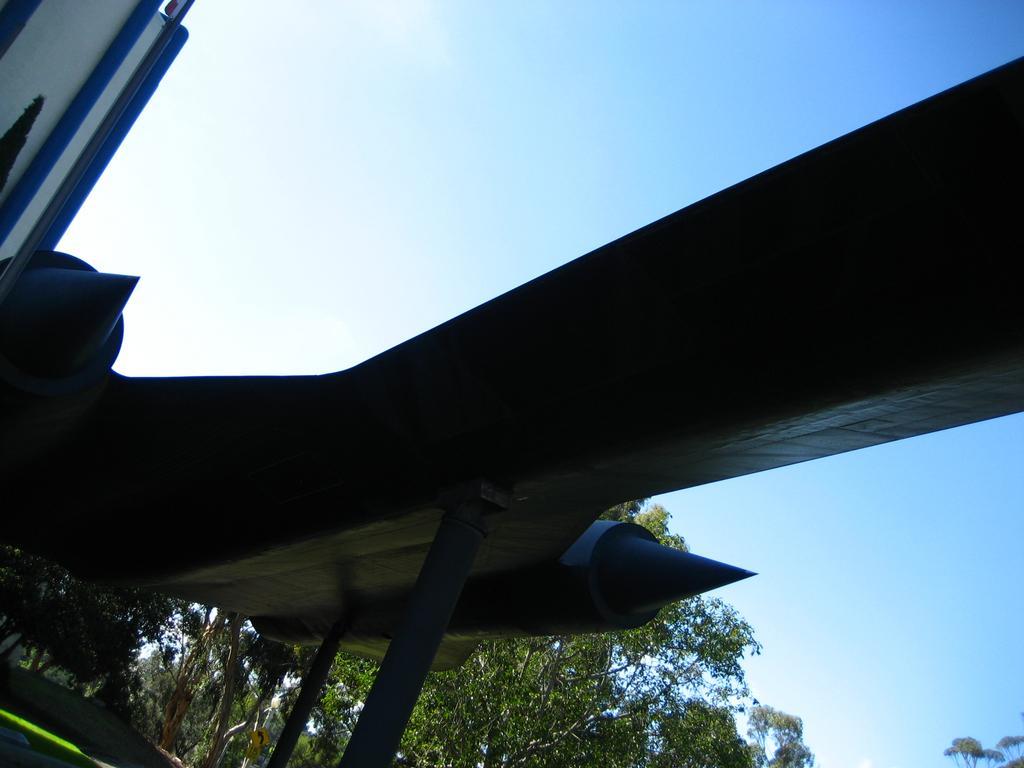Can you describe this image briefly? In this image there is a sculpture behind that there are so many trees. 